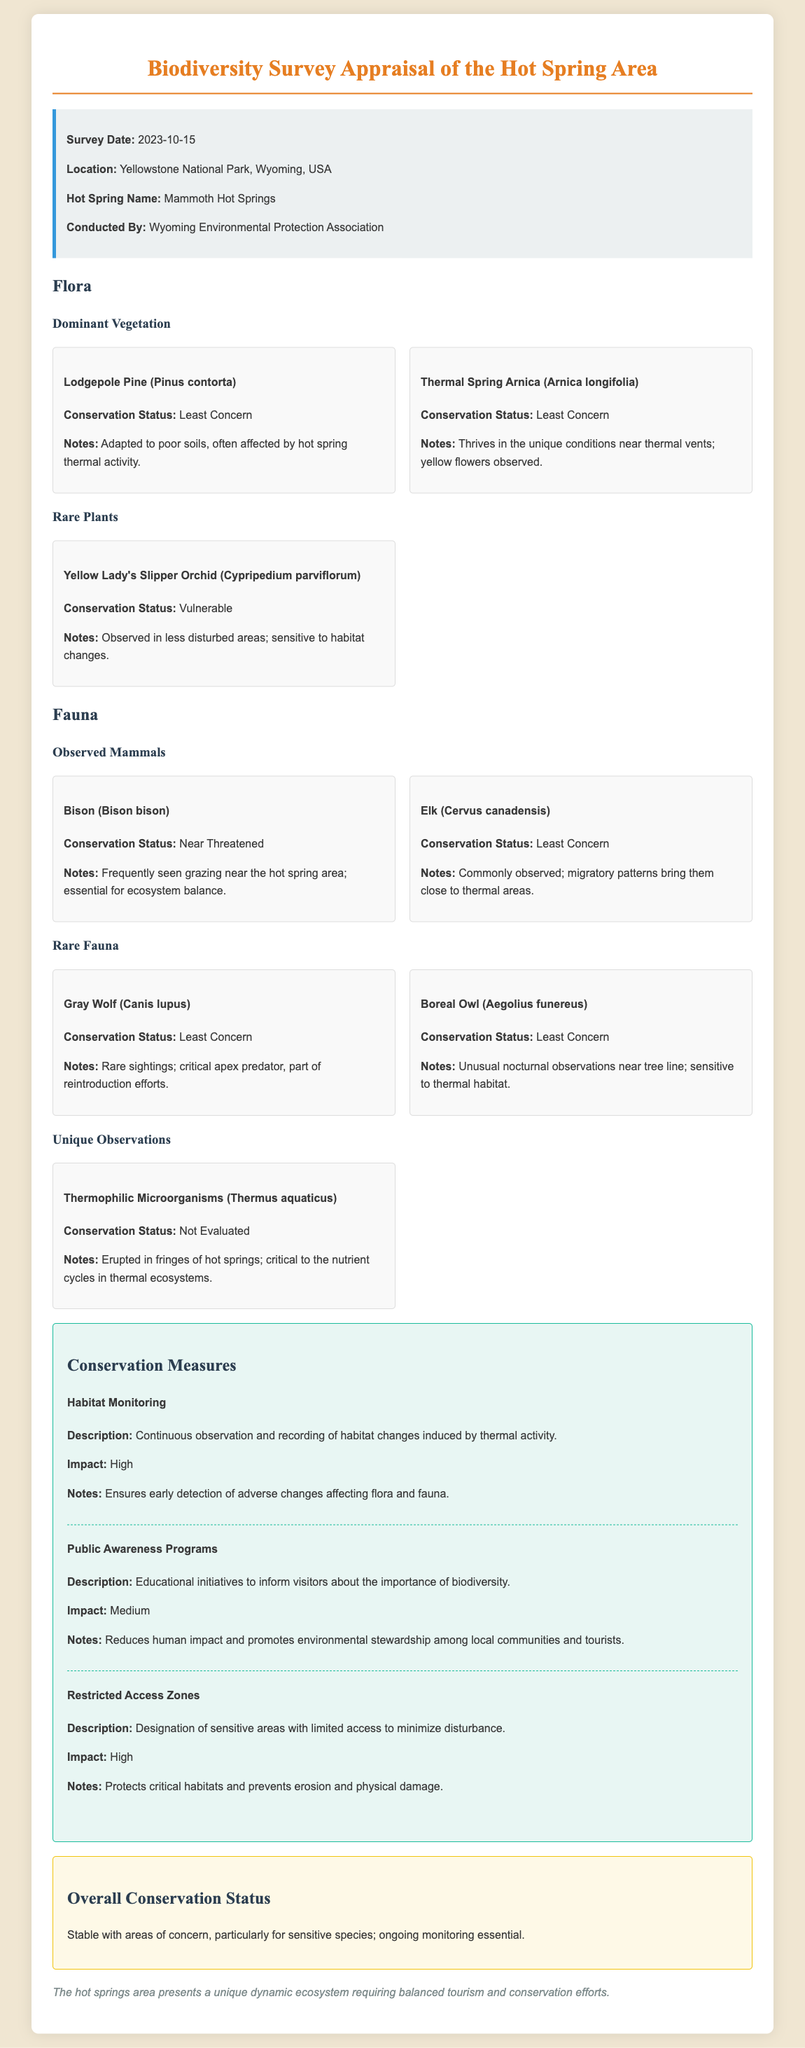What is the survey date? The survey date is listed in the information box at the beginning of the document.
Answer: 2023-10-15 What is the conservation status of the Yellow Lady's Slipper Orchid? The conservation status of the Yellow Lady's Slipper Orchid is mentioned in the rare plants section.
Answer: Vulnerable Which species is described as "frequently seen grazing near the hot spring area"? This information is provided in the observed mammals section, where the conservation status and notes are given.
Answer: Bison What is the primary focus of the public awareness programs? The description of public awareness programs outlines their goal, which can be found under conservation measures.
Answer: Importance of biodiversity What notes are provided for Thermophilic Microorganisms? The notes for Thermophilic Microorganisms elaborate on their ecological role, as stated in the unique observations section.
Answer: Critical to the nutrient cycles in thermal ecosystems 